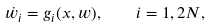Convert formula to latex. <formula><loc_0><loc_0><loc_500><loc_500>\dot { w _ { i } } = g _ { i } ( x , w ) , \quad i = 1 , 2 N ,</formula> 